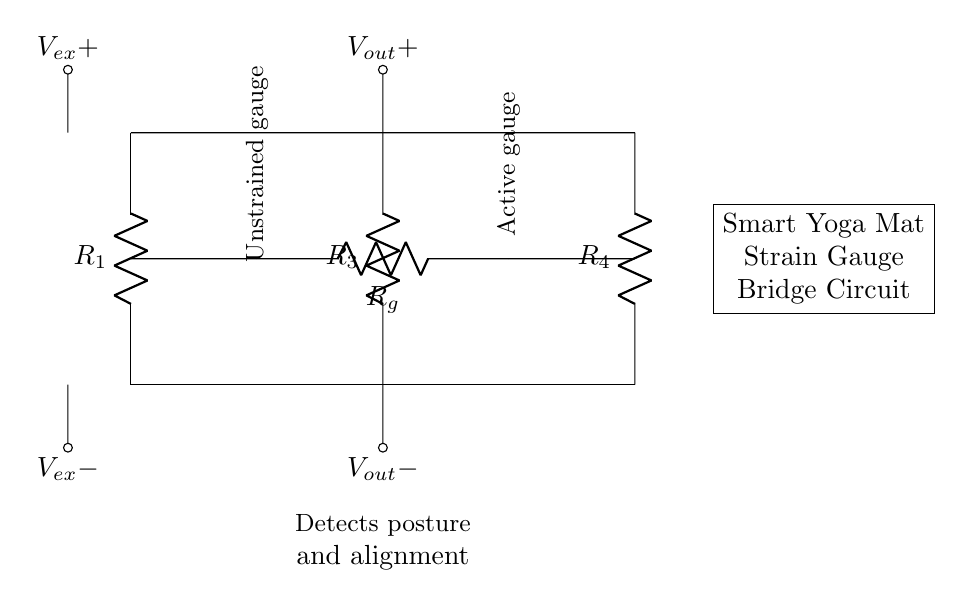What type of circuit is depicted in the diagram? The circuit is a bridge circuit, specifically designed for measuring changes in resistance due to strain gauge applications, like detecting posture.
Answer: bridge circuit How many resistors are present in the circuit? The diagram shows four resistors labeled R1, R2 (the strain gauge), R3, and R4, indicating a total of four resistors in the bridge configuration.
Answer: four What does the output voltage represent in the circuit? The output voltage represents the difference in voltage sensed across the active strain gauge and the other resistors in the bridge, indicating the amount of strain based on resistance change.
Answer: strain Where is the active gauge located in the circuit? The active gauge is represented by R2 in the diagram, which is specifically designated as Rg, indicating it is the resistor responding to applied strain.
Answer: R2 (Rg) What does the circuit detect? The circuit detects posture and alignment through the variations in resistance of the strain gauge when pressure or force is applied on the smart yoga mat's surface.
Answer: posture and alignment What is the significance of the voltage source in the circuit? The voltage source (labeled Vex) provides the necessary excitation voltage for the strain gauge, allowing it to function properly and produce a measurable output voltage proportional to strain.
Answer: excitation voltage Which resistor is unstrained in the circuit? R1 and R4 are indicated to be unstrained, as they are part of the balance of the bridge that does not experience change when strain is applied.
Answer: R1 and R4 